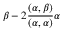<formula> <loc_0><loc_0><loc_500><loc_500>\beta - 2 \frac { ( \alpha , \beta ) } { ( \alpha , \alpha ) } \alpha</formula> 